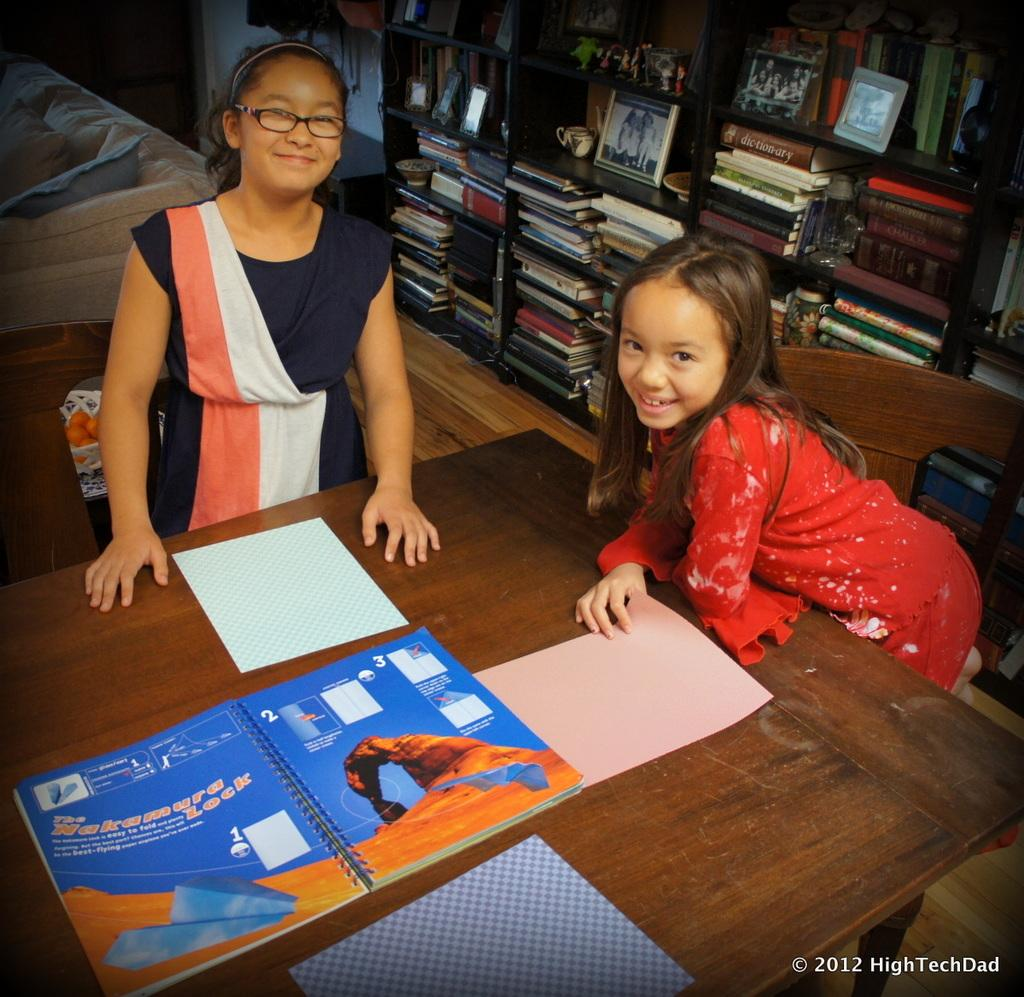How many kids are in the image? There are two kids in the image. Where are the kids located in relation to the table? The kids are standing near a table. What items can be seen on the table? There are books on the table. What can be seen in the background of the image? There are books in the shelves in the background of the image. What type of support can be seen holding up the sheet in the image? There is no sheet or support present in the image. 